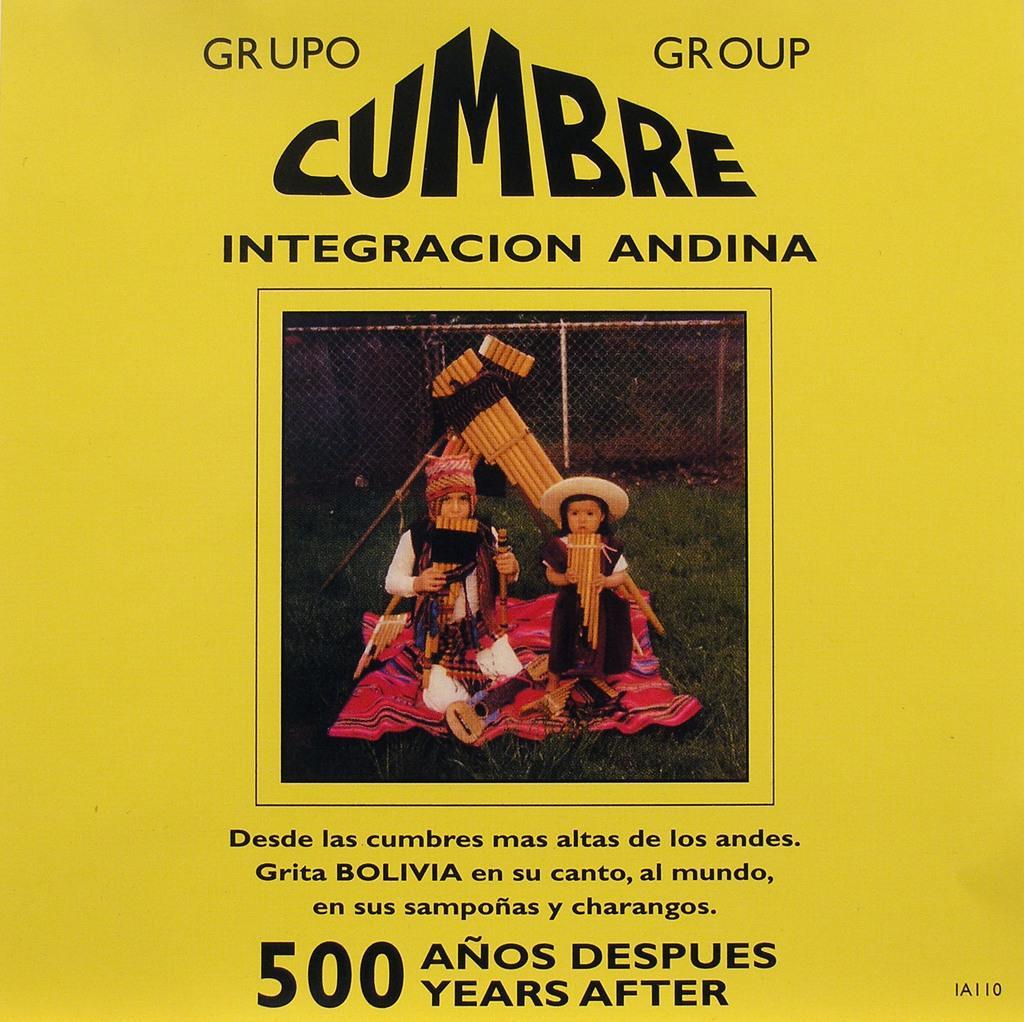Can you describe this image briefly? In this image, I think this is a poster. I can see the picture of two people with the fancy dresses and letters on the poster. The background looks yellow in color. 